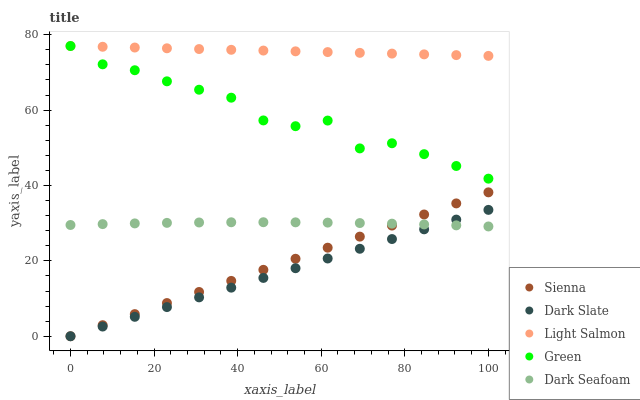Does Dark Slate have the minimum area under the curve?
Answer yes or no. Yes. Does Light Salmon have the maximum area under the curve?
Answer yes or no. Yes. Does Light Salmon have the minimum area under the curve?
Answer yes or no. No. Does Dark Slate have the maximum area under the curve?
Answer yes or no. No. Is Dark Slate the smoothest?
Answer yes or no. Yes. Is Green the roughest?
Answer yes or no. Yes. Is Light Salmon the smoothest?
Answer yes or no. No. Is Light Salmon the roughest?
Answer yes or no. No. Does Sienna have the lowest value?
Answer yes or no. Yes. Does Light Salmon have the lowest value?
Answer yes or no. No. Does Green have the highest value?
Answer yes or no. Yes. Does Dark Slate have the highest value?
Answer yes or no. No. Is Sienna less than Light Salmon?
Answer yes or no. Yes. Is Green greater than Dark Slate?
Answer yes or no. Yes. Does Sienna intersect Dark Seafoam?
Answer yes or no. Yes. Is Sienna less than Dark Seafoam?
Answer yes or no. No. Is Sienna greater than Dark Seafoam?
Answer yes or no. No. Does Sienna intersect Light Salmon?
Answer yes or no. No. 